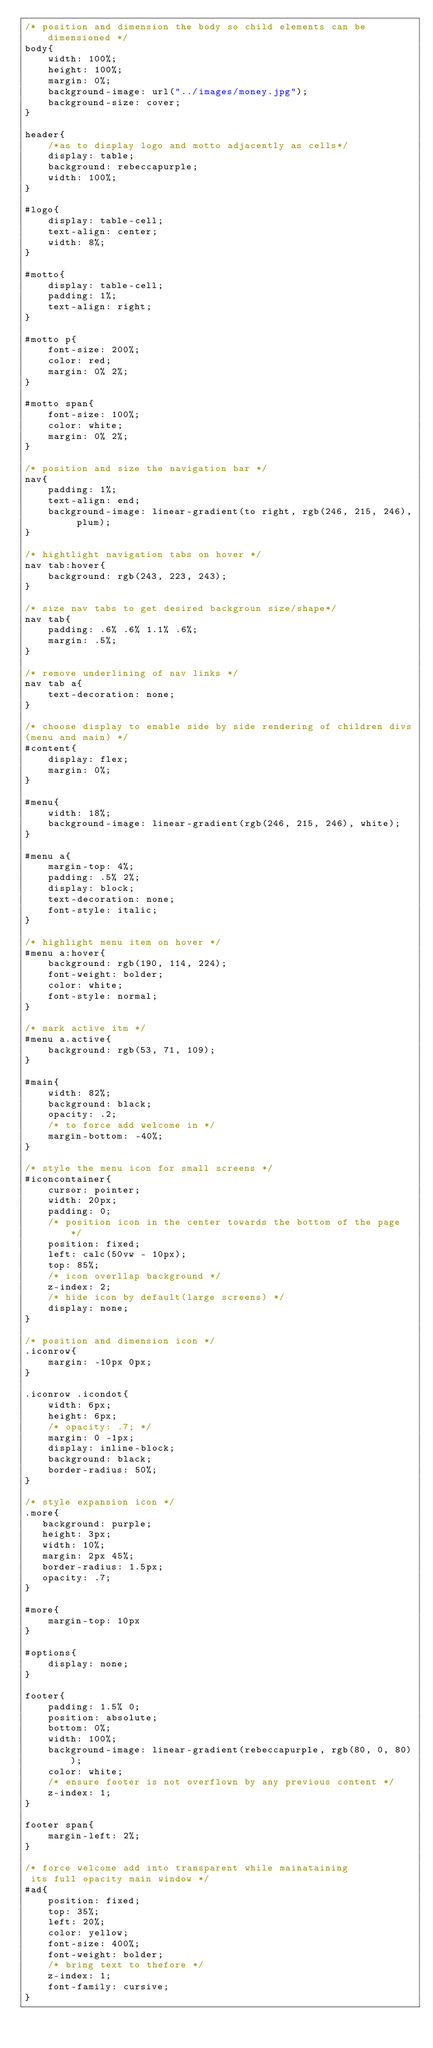<code> <loc_0><loc_0><loc_500><loc_500><_CSS_>/* position and dimension the body so child elements can be dimensioned */
body{
    width: 100%;
    height: 100%;
    margin: 0%;
    background-image: url("../images/money.jpg");
    background-size: cover;
}

header{
    /*as to display logo and motto adjacently as cells*/
    display: table;
    background: rebeccapurple;
    width: 100%;
}

#logo{
    display: table-cell;
    text-align: center;
    width: 8%;
}

#motto{
    display: table-cell;
    padding: 1%;
    text-align: right;
}

#motto p{
    font-size: 200%;
    color: red;
    margin: 0% 2%;
}

#motto span{
    font-size: 100%;
    color: white;
    margin: 0% 2%;
}

/* position and size the navigation bar */
nav{
    padding: 1%;
    text-align: end;
    background-image: linear-gradient(to right, rgb(246, 215, 246), plum);
}

/* hightlight navigation tabs on hover */
nav tab:hover{
    background: rgb(243, 223, 243);
}

/* size nav tabs to get desired backgroun size/shape*/
nav tab{
    padding: .6% .6% 1.1% .6%;
    margin: .5%;
}

/* remove underlining of nav links */
nav tab a{
    text-decoration: none;
}

/* choose display to enable side by side rendering of children divs
(menu and main) */
#content{
    display: flex;
    margin: 0%;
}

#menu{
    width: 18%;
    background-image: linear-gradient(rgb(246, 215, 246), white);
}

#menu a{
    margin-top: 4%;
    padding: .5% 2%;
    display: block;
    text-decoration: none;
    font-style: italic;
}

/* highlight menu item on hover */
#menu a:hover{
    background: rgb(190, 114, 224);
    font-weight: bolder;
    color: white;
    font-style: normal;
}

/* mark active itm */
#menu a.active{
    background: rgb(53, 71, 109);
}

#main{
    width: 82%;
    background: black;
    opacity: .2;
    /* to force add welcome in */
    margin-bottom: -40%;
}

/* style the menu icon for small screens */
#iconcontainer{
    cursor: pointer;
    width: 20px;
    padding: 0;
    /* position icon in the center towards the bottom of the page */
    position: fixed;
    left: calc(50vw - 10px);
    top: 85%;
    /* icon overllap background */
    z-index: 2;
    /* hide icon by default(large screens) */
    display: none;
}

/* position and dimension icon */
.iconrow{
    margin: -10px 0px;
}

.iconrow .icondot{
    width: 6px;
    height: 6px;
    /* opacity: .7; */
    margin: 0 -1px;
    display: inline-block;
    background: black;
    border-radius: 50%;
}

/* style expansion icon */
.more{
   background: purple;
   height: 3px;
   width: 10%;
   margin: 2px 45%;
   border-radius: 1.5px;
   opacity: .7;
}

#more{
    margin-top: 10px
}

#options{
    display: none;
}

footer{
    padding: 1.5% 0;
    position: absolute;
    bottom: 0%;
    width: 100%;
    background-image: linear-gradient(rebeccapurple, rgb(80, 0, 80));
    color: white;
    /* ensure footer is not overflown by any previous content */
    z-index: 1;
}

footer span{
    margin-left: 2%;
}

/* force welcome add into transparent while mainataining
 its full opacity main window */
#ad{
    position: fixed;
    top: 35%;
    left: 20%;
    color: yellow;
    font-size: 400%;
    font-weight: bolder;
    /* bring text to thefore */
    z-index: 1;
    font-family: cursive;
}
</code> 